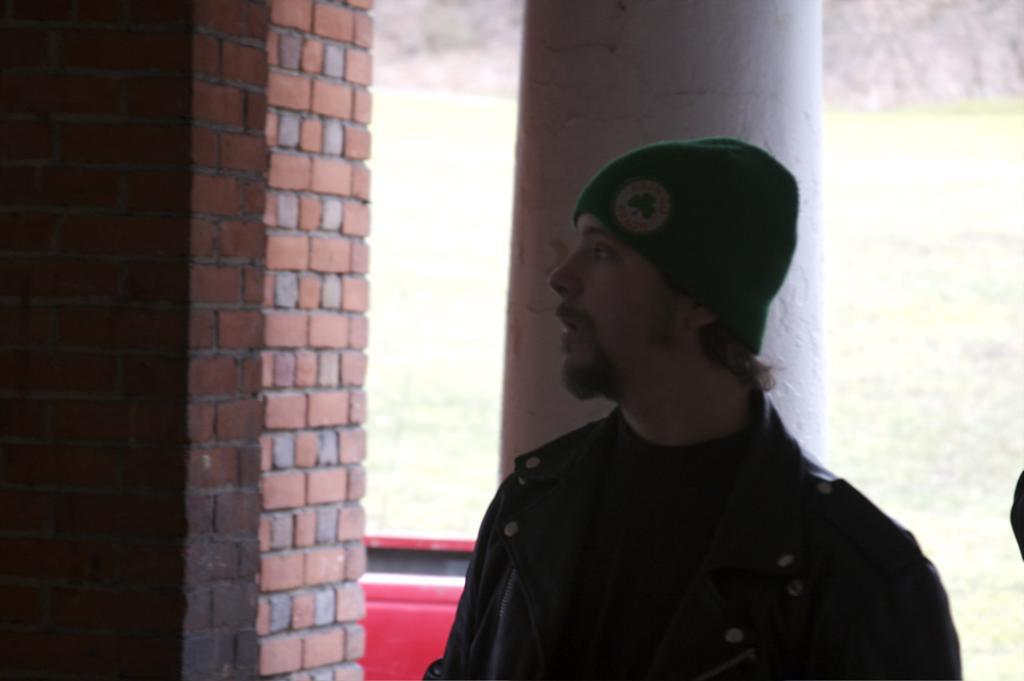What is the main subject of the image? There is a man standing in the image. What is located behind the man? There is a pillar behind the man. What is to the left of the man? There is a wall to the left of the man. What type of vegetation can be seen in the background of the image? There is grass on the ground in the background of the image. What type of beef can be seen cooking on a grill in the image? There is no beef or grill present in the image; it features a man standing with a pillar and a wall nearby. 